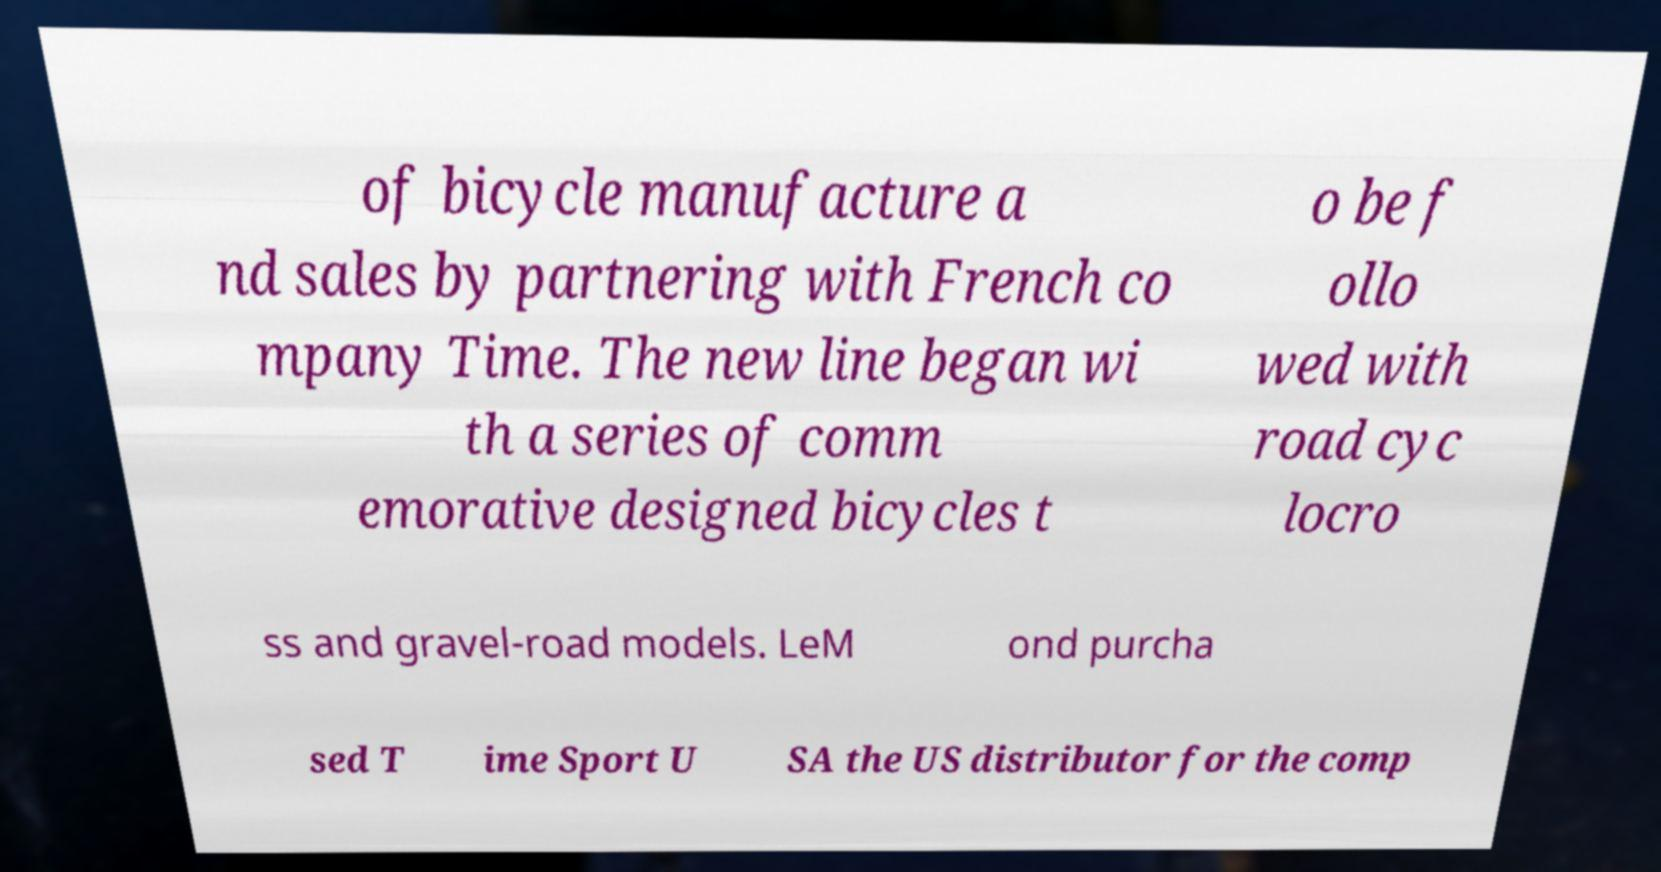What messages or text are displayed in this image? I need them in a readable, typed format. of bicycle manufacture a nd sales by partnering with French co mpany Time. The new line began wi th a series of comm emorative designed bicycles t o be f ollo wed with road cyc locro ss and gravel-road models. LeM ond purcha sed T ime Sport U SA the US distributor for the comp 